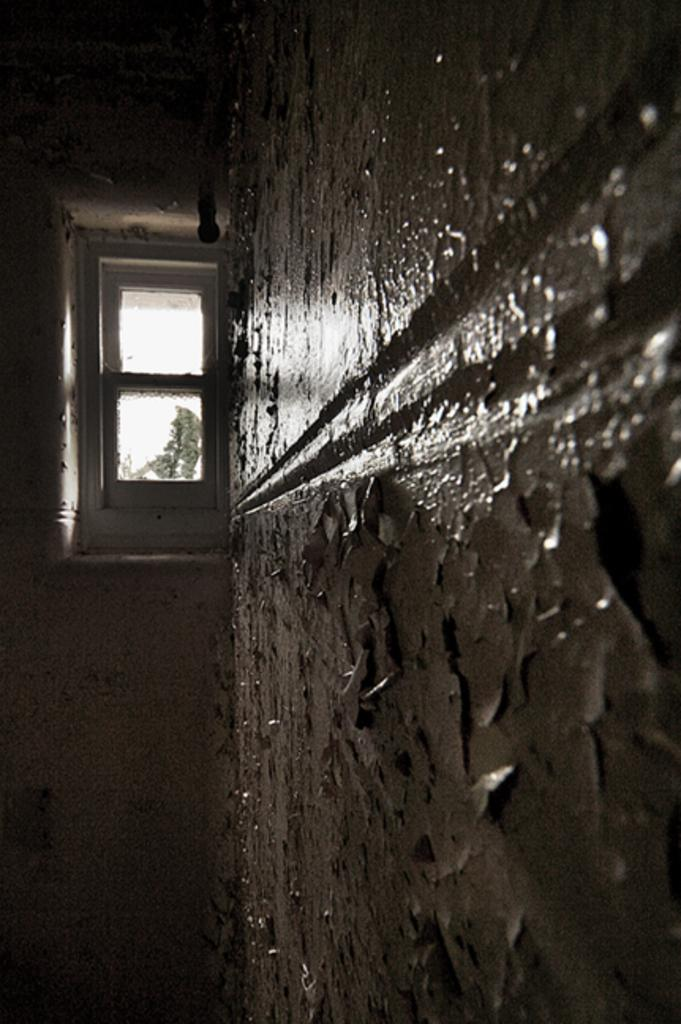What type of space is depicted in the image? The image shows an inside view of a room. What can be seen on the right side of the room? There is a wall on the right side of the room. What feature is present on the left side of the room? There is a window on the left side of the room. What is visible through the window? Trees and the sky are visible through the window. Can you tell me how many fairies are sitting on the window sill in the image? There are no fairies present in the image; it shows an inside view of a room with a window and trees visible through it. 